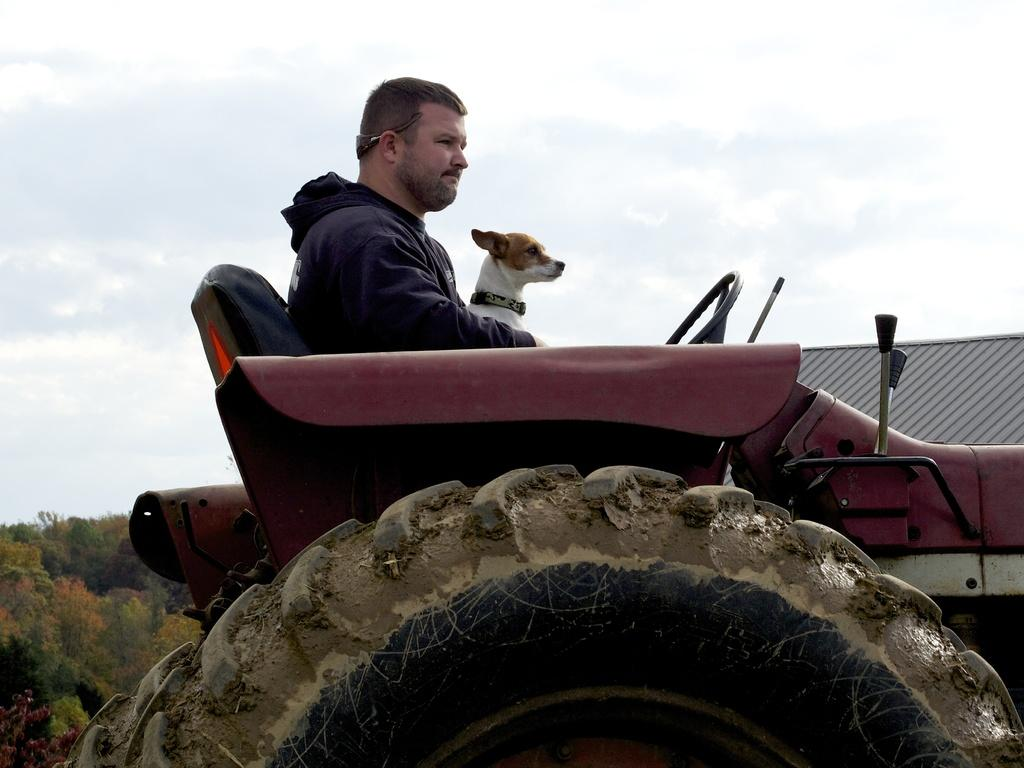Who or what can be seen in the image? There is a man and a dog in the image. What are the man and the dog doing in the image? Both the man and the dog are sitting in a vehicle. What can be seen in the background of the image? There is a tree and the sky visible in the background of the image. What type of lumber is being used to construct the vehicle in the image? There is no mention of lumber or the construction of the vehicle in the image. The vehicle appears to be a regular car or truck. How does the rainstorm affect the man and the dog in the image? There is no rainstorm present in the image. The sky is visible, but it does not show any signs of rain. 